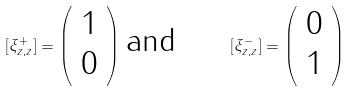Convert formula to latex. <formula><loc_0><loc_0><loc_500><loc_500>[ \xi _ { z , z } ^ { + } ] = \left ( \begin{array} { c } 1 \\ 0 \end{array} \right ) \, \text {and\quad \ \ } [ \xi _ { z , z } ^ { - } ] = \left ( \begin{array} { c } 0 \\ 1 \end{array} \right )</formula> 